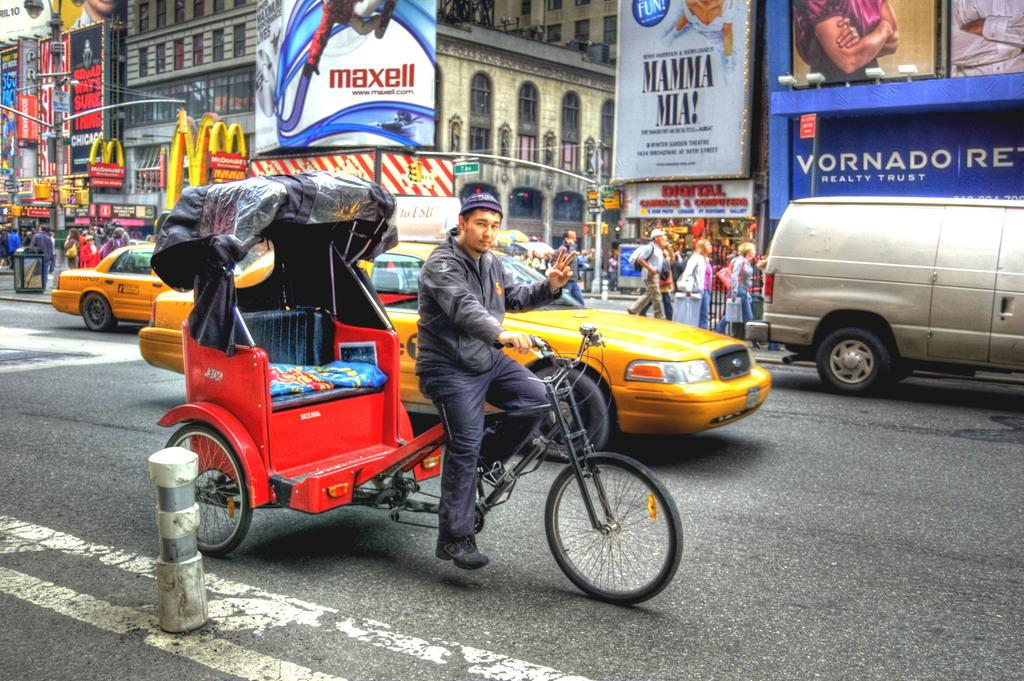Provide a one-sentence caption for the provided image. a vornado sign that is next to the street. 